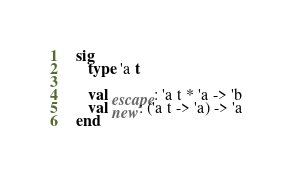<code> <loc_0><loc_0><loc_500><loc_500><_SML_>   sig
      type 'a t

      val escape: 'a t * 'a -> 'b
      val new: ('a t -> 'a) -> 'a
   end
</code> 